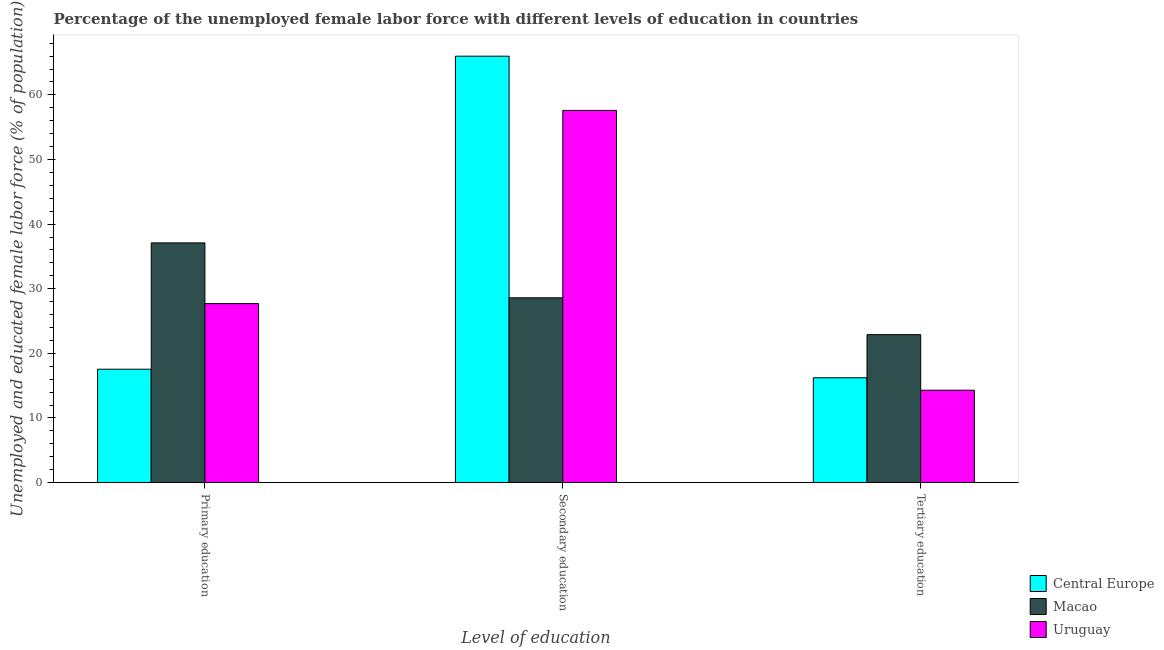How many different coloured bars are there?
Ensure brevity in your answer.  3. How many groups of bars are there?
Offer a very short reply. 3. Are the number of bars per tick equal to the number of legend labels?
Offer a terse response. Yes. What is the label of the 1st group of bars from the left?
Provide a succinct answer. Primary education. What is the percentage of female labor force who received primary education in Central Europe?
Offer a very short reply. 17.55. Across all countries, what is the maximum percentage of female labor force who received tertiary education?
Ensure brevity in your answer.  22.9. Across all countries, what is the minimum percentage of female labor force who received primary education?
Your answer should be compact. 17.55. In which country was the percentage of female labor force who received tertiary education maximum?
Offer a very short reply. Macao. In which country was the percentage of female labor force who received secondary education minimum?
Ensure brevity in your answer.  Macao. What is the total percentage of female labor force who received secondary education in the graph?
Your answer should be compact. 152.19. What is the difference between the percentage of female labor force who received tertiary education in Central Europe and that in Uruguay?
Offer a terse response. 1.92. What is the difference between the percentage of female labor force who received tertiary education in Uruguay and the percentage of female labor force who received primary education in Macao?
Offer a terse response. -22.8. What is the average percentage of female labor force who received secondary education per country?
Your answer should be very brief. 50.73. What is the difference between the percentage of female labor force who received secondary education and percentage of female labor force who received primary education in Central Europe?
Your answer should be compact. 48.44. In how many countries, is the percentage of female labor force who received primary education greater than 18 %?
Your answer should be very brief. 2. What is the ratio of the percentage of female labor force who received tertiary education in Central Europe to that in Macao?
Your answer should be very brief. 0.71. Is the percentage of female labor force who received secondary education in Uruguay less than that in Macao?
Your response must be concise. No. What is the difference between the highest and the second highest percentage of female labor force who received secondary education?
Provide a succinct answer. 8.39. What is the difference between the highest and the lowest percentage of female labor force who received primary education?
Your response must be concise. 19.55. What does the 2nd bar from the left in Primary education represents?
Give a very brief answer. Macao. What does the 1st bar from the right in Primary education represents?
Make the answer very short. Uruguay. How many bars are there?
Give a very brief answer. 9. What is the difference between two consecutive major ticks on the Y-axis?
Ensure brevity in your answer.  10. Does the graph contain grids?
Your answer should be compact. No. How are the legend labels stacked?
Offer a very short reply. Vertical. What is the title of the graph?
Your answer should be compact. Percentage of the unemployed female labor force with different levels of education in countries. Does "Finland" appear as one of the legend labels in the graph?
Make the answer very short. No. What is the label or title of the X-axis?
Your answer should be compact. Level of education. What is the label or title of the Y-axis?
Give a very brief answer. Unemployed and educated female labor force (% of population). What is the Unemployed and educated female labor force (% of population) in Central Europe in Primary education?
Offer a terse response. 17.55. What is the Unemployed and educated female labor force (% of population) in Macao in Primary education?
Keep it short and to the point. 37.1. What is the Unemployed and educated female labor force (% of population) in Uruguay in Primary education?
Provide a short and direct response. 27.7. What is the Unemployed and educated female labor force (% of population) in Central Europe in Secondary education?
Your answer should be very brief. 65.99. What is the Unemployed and educated female labor force (% of population) in Macao in Secondary education?
Keep it short and to the point. 28.6. What is the Unemployed and educated female labor force (% of population) in Uruguay in Secondary education?
Offer a terse response. 57.6. What is the Unemployed and educated female labor force (% of population) of Central Europe in Tertiary education?
Offer a very short reply. 16.22. What is the Unemployed and educated female labor force (% of population) of Macao in Tertiary education?
Provide a succinct answer. 22.9. What is the Unemployed and educated female labor force (% of population) in Uruguay in Tertiary education?
Offer a very short reply. 14.3. Across all Level of education, what is the maximum Unemployed and educated female labor force (% of population) of Central Europe?
Offer a terse response. 65.99. Across all Level of education, what is the maximum Unemployed and educated female labor force (% of population) in Macao?
Keep it short and to the point. 37.1. Across all Level of education, what is the maximum Unemployed and educated female labor force (% of population) of Uruguay?
Your response must be concise. 57.6. Across all Level of education, what is the minimum Unemployed and educated female labor force (% of population) in Central Europe?
Offer a terse response. 16.22. Across all Level of education, what is the minimum Unemployed and educated female labor force (% of population) in Macao?
Provide a short and direct response. 22.9. Across all Level of education, what is the minimum Unemployed and educated female labor force (% of population) of Uruguay?
Offer a terse response. 14.3. What is the total Unemployed and educated female labor force (% of population) in Central Europe in the graph?
Provide a succinct answer. 99.77. What is the total Unemployed and educated female labor force (% of population) of Macao in the graph?
Provide a succinct answer. 88.6. What is the total Unemployed and educated female labor force (% of population) of Uruguay in the graph?
Offer a very short reply. 99.6. What is the difference between the Unemployed and educated female labor force (% of population) in Central Europe in Primary education and that in Secondary education?
Keep it short and to the point. -48.44. What is the difference between the Unemployed and educated female labor force (% of population) of Uruguay in Primary education and that in Secondary education?
Offer a very short reply. -29.9. What is the difference between the Unemployed and educated female labor force (% of population) of Central Europe in Primary education and that in Tertiary education?
Offer a very short reply. 1.33. What is the difference between the Unemployed and educated female labor force (% of population) of Uruguay in Primary education and that in Tertiary education?
Your response must be concise. 13.4. What is the difference between the Unemployed and educated female labor force (% of population) in Central Europe in Secondary education and that in Tertiary education?
Provide a short and direct response. 49.77. What is the difference between the Unemployed and educated female labor force (% of population) in Macao in Secondary education and that in Tertiary education?
Offer a very short reply. 5.7. What is the difference between the Unemployed and educated female labor force (% of population) of Uruguay in Secondary education and that in Tertiary education?
Offer a terse response. 43.3. What is the difference between the Unemployed and educated female labor force (% of population) in Central Europe in Primary education and the Unemployed and educated female labor force (% of population) in Macao in Secondary education?
Your answer should be compact. -11.05. What is the difference between the Unemployed and educated female labor force (% of population) in Central Europe in Primary education and the Unemployed and educated female labor force (% of population) in Uruguay in Secondary education?
Keep it short and to the point. -40.05. What is the difference between the Unemployed and educated female labor force (% of population) in Macao in Primary education and the Unemployed and educated female labor force (% of population) in Uruguay in Secondary education?
Give a very brief answer. -20.5. What is the difference between the Unemployed and educated female labor force (% of population) in Central Europe in Primary education and the Unemployed and educated female labor force (% of population) in Macao in Tertiary education?
Your response must be concise. -5.35. What is the difference between the Unemployed and educated female labor force (% of population) of Macao in Primary education and the Unemployed and educated female labor force (% of population) of Uruguay in Tertiary education?
Provide a short and direct response. 22.8. What is the difference between the Unemployed and educated female labor force (% of population) of Central Europe in Secondary education and the Unemployed and educated female labor force (% of population) of Macao in Tertiary education?
Provide a succinct answer. 43.09. What is the difference between the Unemployed and educated female labor force (% of population) in Central Europe in Secondary education and the Unemployed and educated female labor force (% of population) in Uruguay in Tertiary education?
Your response must be concise. 51.69. What is the average Unemployed and educated female labor force (% of population) of Central Europe per Level of education?
Your response must be concise. 33.26. What is the average Unemployed and educated female labor force (% of population) in Macao per Level of education?
Give a very brief answer. 29.53. What is the average Unemployed and educated female labor force (% of population) in Uruguay per Level of education?
Your response must be concise. 33.2. What is the difference between the Unemployed and educated female labor force (% of population) of Central Europe and Unemployed and educated female labor force (% of population) of Macao in Primary education?
Keep it short and to the point. -19.55. What is the difference between the Unemployed and educated female labor force (% of population) in Central Europe and Unemployed and educated female labor force (% of population) in Uruguay in Primary education?
Your answer should be very brief. -10.15. What is the difference between the Unemployed and educated female labor force (% of population) of Central Europe and Unemployed and educated female labor force (% of population) of Macao in Secondary education?
Provide a short and direct response. 37.39. What is the difference between the Unemployed and educated female labor force (% of population) in Central Europe and Unemployed and educated female labor force (% of population) in Uruguay in Secondary education?
Your response must be concise. 8.39. What is the difference between the Unemployed and educated female labor force (% of population) of Central Europe and Unemployed and educated female labor force (% of population) of Macao in Tertiary education?
Make the answer very short. -6.68. What is the difference between the Unemployed and educated female labor force (% of population) of Central Europe and Unemployed and educated female labor force (% of population) of Uruguay in Tertiary education?
Offer a terse response. 1.92. What is the difference between the Unemployed and educated female labor force (% of population) in Macao and Unemployed and educated female labor force (% of population) in Uruguay in Tertiary education?
Your response must be concise. 8.6. What is the ratio of the Unemployed and educated female labor force (% of population) in Central Europe in Primary education to that in Secondary education?
Ensure brevity in your answer.  0.27. What is the ratio of the Unemployed and educated female labor force (% of population) in Macao in Primary education to that in Secondary education?
Provide a short and direct response. 1.3. What is the ratio of the Unemployed and educated female labor force (% of population) in Uruguay in Primary education to that in Secondary education?
Your answer should be very brief. 0.48. What is the ratio of the Unemployed and educated female labor force (% of population) of Central Europe in Primary education to that in Tertiary education?
Provide a succinct answer. 1.08. What is the ratio of the Unemployed and educated female labor force (% of population) of Macao in Primary education to that in Tertiary education?
Provide a short and direct response. 1.62. What is the ratio of the Unemployed and educated female labor force (% of population) in Uruguay in Primary education to that in Tertiary education?
Your answer should be compact. 1.94. What is the ratio of the Unemployed and educated female labor force (% of population) in Central Europe in Secondary education to that in Tertiary education?
Offer a terse response. 4.07. What is the ratio of the Unemployed and educated female labor force (% of population) in Macao in Secondary education to that in Tertiary education?
Ensure brevity in your answer.  1.25. What is the ratio of the Unemployed and educated female labor force (% of population) of Uruguay in Secondary education to that in Tertiary education?
Make the answer very short. 4.03. What is the difference between the highest and the second highest Unemployed and educated female labor force (% of population) of Central Europe?
Provide a succinct answer. 48.44. What is the difference between the highest and the second highest Unemployed and educated female labor force (% of population) of Macao?
Your response must be concise. 8.5. What is the difference between the highest and the second highest Unemployed and educated female labor force (% of population) in Uruguay?
Your response must be concise. 29.9. What is the difference between the highest and the lowest Unemployed and educated female labor force (% of population) in Central Europe?
Make the answer very short. 49.77. What is the difference between the highest and the lowest Unemployed and educated female labor force (% of population) in Uruguay?
Ensure brevity in your answer.  43.3. 